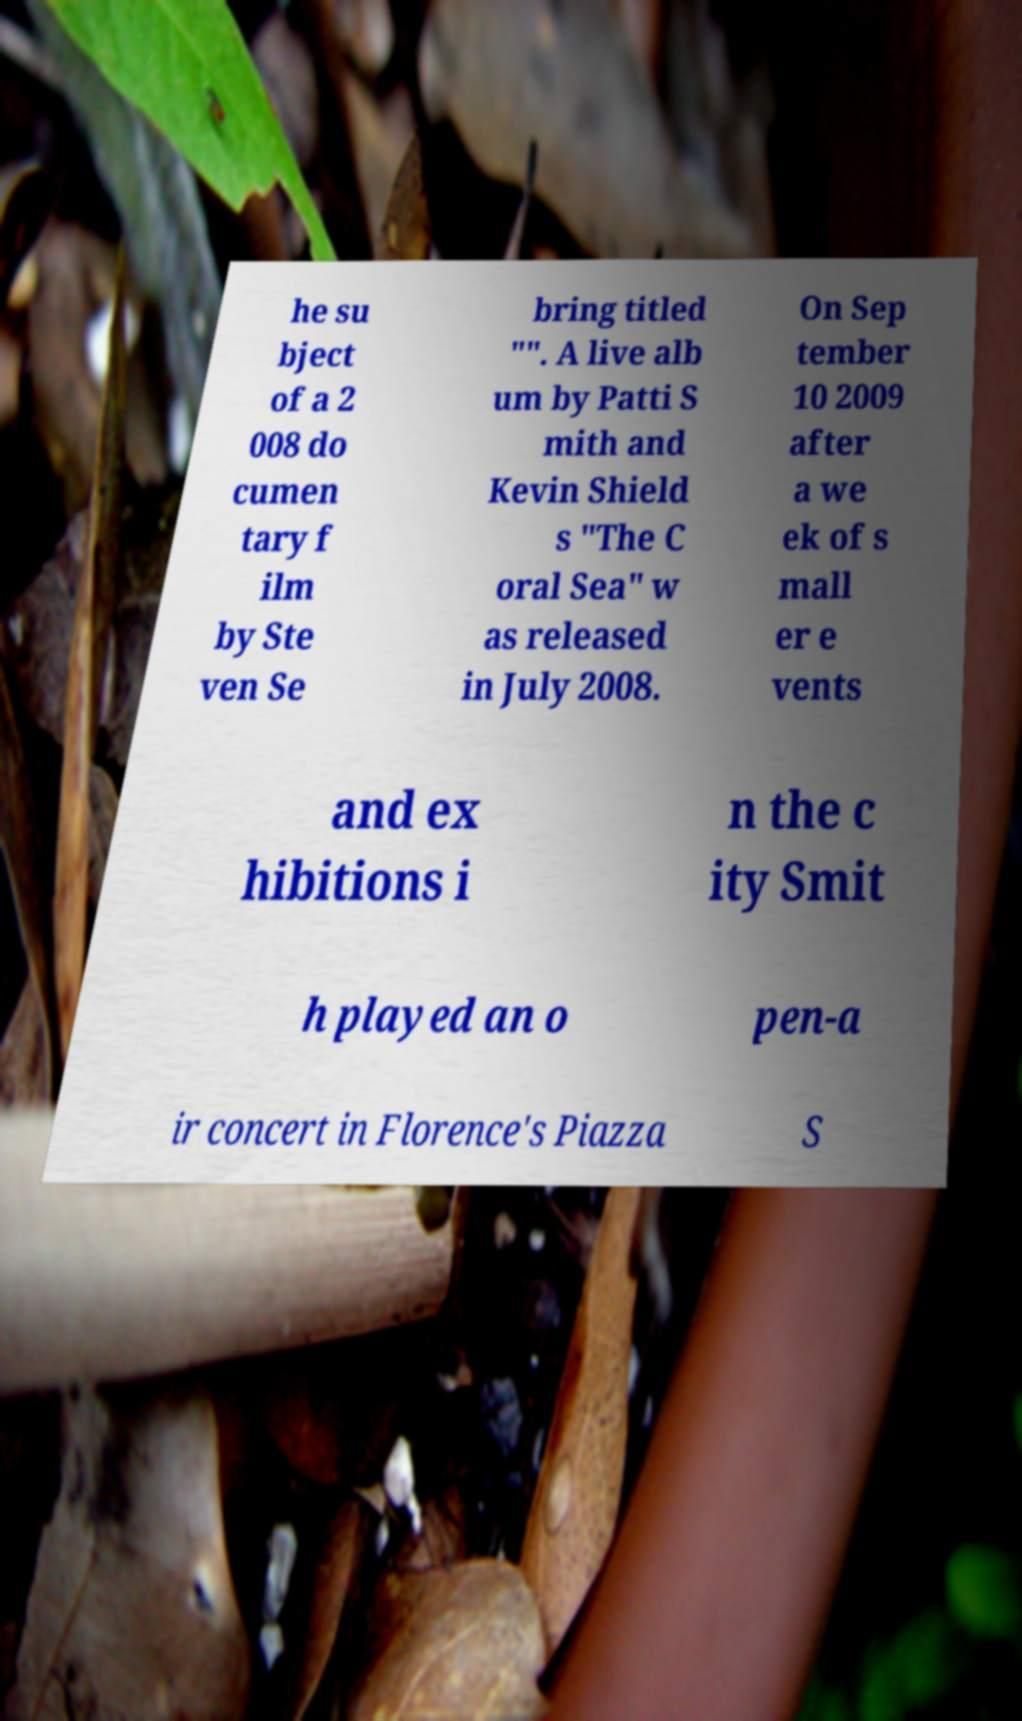What messages or text are displayed in this image? I need them in a readable, typed format. he su bject of a 2 008 do cumen tary f ilm by Ste ven Se bring titled "". A live alb um by Patti S mith and Kevin Shield s "The C oral Sea" w as released in July 2008. On Sep tember 10 2009 after a we ek of s mall er e vents and ex hibitions i n the c ity Smit h played an o pen-a ir concert in Florence's Piazza S 